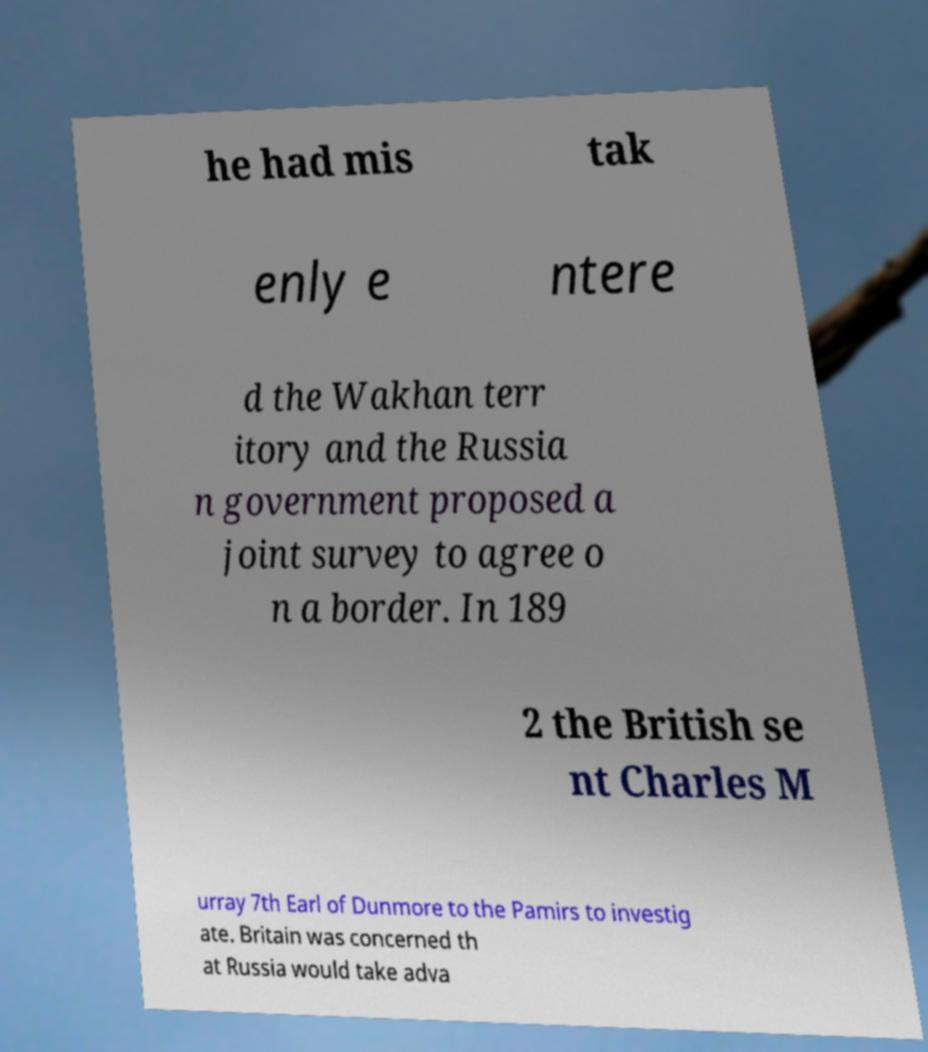Could you assist in decoding the text presented in this image and type it out clearly? he had mis tak enly e ntere d the Wakhan terr itory and the Russia n government proposed a joint survey to agree o n a border. In 189 2 the British se nt Charles M urray 7th Earl of Dunmore to the Pamirs to investig ate. Britain was concerned th at Russia would take adva 